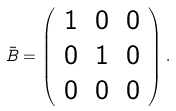<formula> <loc_0><loc_0><loc_500><loc_500>\bar { B } = \left ( \begin{array} { c c c } 1 & 0 & 0 \\ 0 & 1 & 0 \\ 0 & 0 & 0 \end{array} \right ) .</formula> 